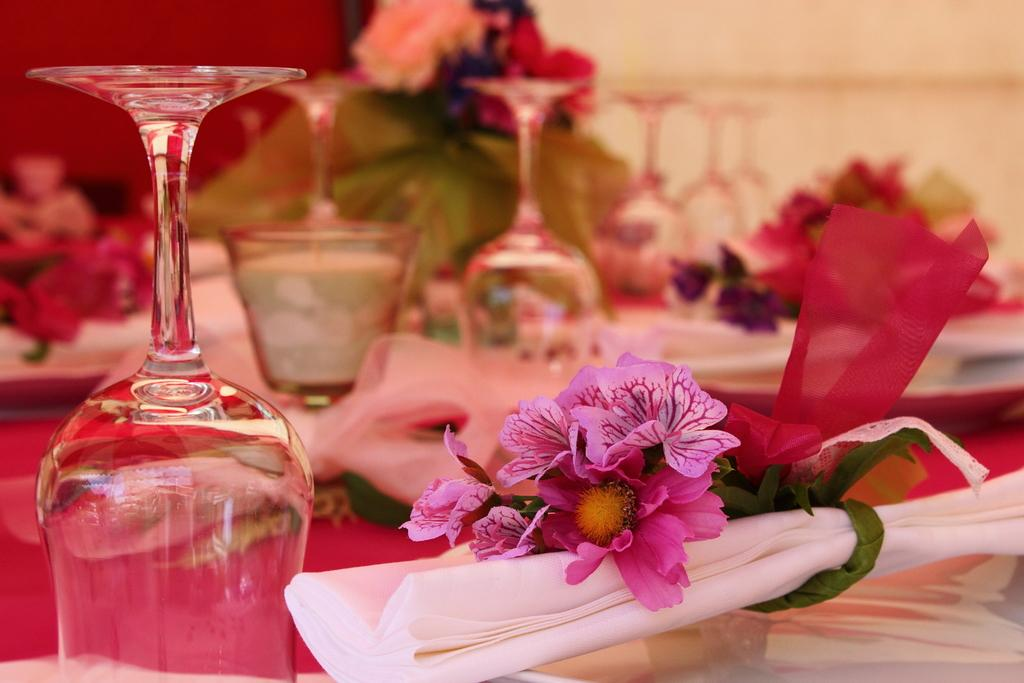What is present in the image that can hold liquids? There is a glass in the image that can hold liquids. What type of decorative items can be seen in the image? There are flowers in the image. What is on top of the glass in the image? There are objects on the glass. What type of background is visible in the image? There is a wall visible in the image. What type of arch can be seen in the image? There is no arch present in the image. How does the destruction of the glass affect the flowers in the image? The image does not depict any destruction of the glass or the flowers; they are both intact. 